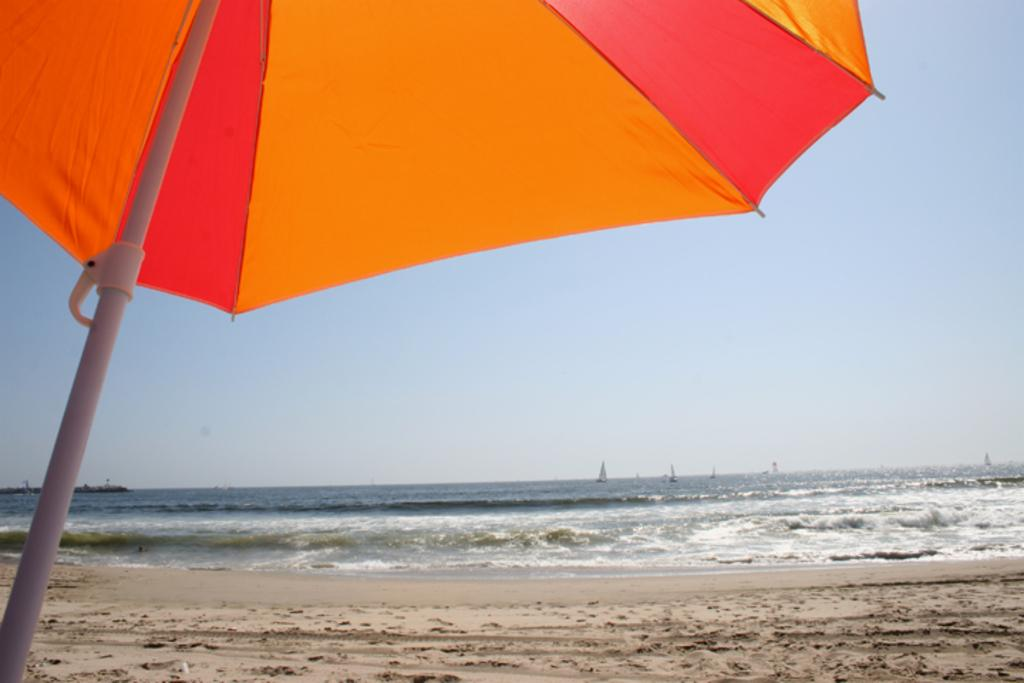What type of umbrella is on the left side of the image? There is an orange and red color umbrella on the left side of the image. What is the ground made of in the image? There is sand on the ground in the image. What can be seen in the background of the image? There is water visible in the background of the image. What is visible at the top of the image? The sky is visible at the top of the image. What type of steel is used to construct the governor's train in the image? There is no train or governor present in the image, so it is not possible to determine the type of steel used for construction. 